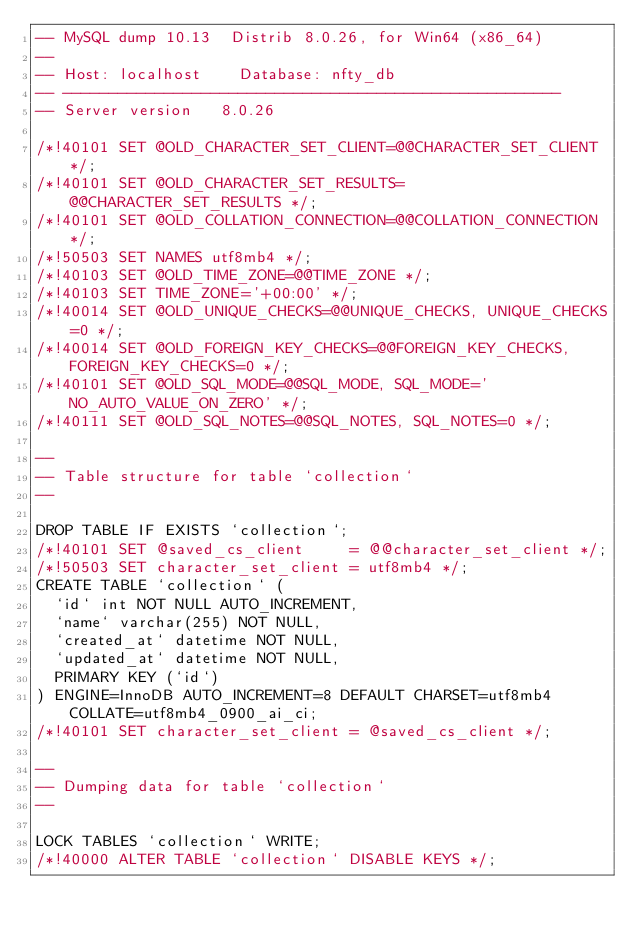<code> <loc_0><loc_0><loc_500><loc_500><_SQL_>-- MySQL dump 10.13  Distrib 8.0.26, for Win64 (x86_64)
--
-- Host: localhost    Database: nfty_db
-- ------------------------------------------------------
-- Server version	8.0.26

/*!40101 SET @OLD_CHARACTER_SET_CLIENT=@@CHARACTER_SET_CLIENT */;
/*!40101 SET @OLD_CHARACTER_SET_RESULTS=@@CHARACTER_SET_RESULTS */;
/*!40101 SET @OLD_COLLATION_CONNECTION=@@COLLATION_CONNECTION */;
/*!50503 SET NAMES utf8mb4 */;
/*!40103 SET @OLD_TIME_ZONE=@@TIME_ZONE */;
/*!40103 SET TIME_ZONE='+00:00' */;
/*!40014 SET @OLD_UNIQUE_CHECKS=@@UNIQUE_CHECKS, UNIQUE_CHECKS=0 */;
/*!40014 SET @OLD_FOREIGN_KEY_CHECKS=@@FOREIGN_KEY_CHECKS, FOREIGN_KEY_CHECKS=0 */;
/*!40101 SET @OLD_SQL_MODE=@@SQL_MODE, SQL_MODE='NO_AUTO_VALUE_ON_ZERO' */;
/*!40111 SET @OLD_SQL_NOTES=@@SQL_NOTES, SQL_NOTES=0 */;

--
-- Table structure for table `collection`
--

DROP TABLE IF EXISTS `collection`;
/*!40101 SET @saved_cs_client     = @@character_set_client */;
/*!50503 SET character_set_client = utf8mb4 */;
CREATE TABLE `collection` (
  `id` int NOT NULL AUTO_INCREMENT,
  `name` varchar(255) NOT NULL,
  `created_at` datetime NOT NULL,
  `updated_at` datetime NOT NULL,
  PRIMARY KEY (`id`)
) ENGINE=InnoDB AUTO_INCREMENT=8 DEFAULT CHARSET=utf8mb4 COLLATE=utf8mb4_0900_ai_ci;
/*!40101 SET character_set_client = @saved_cs_client */;

--
-- Dumping data for table `collection`
--

LOCK TABLES `collection` WRITE;
/*!40000 ALTER TABLE `collection` DISABLE KEYS */;</code> 